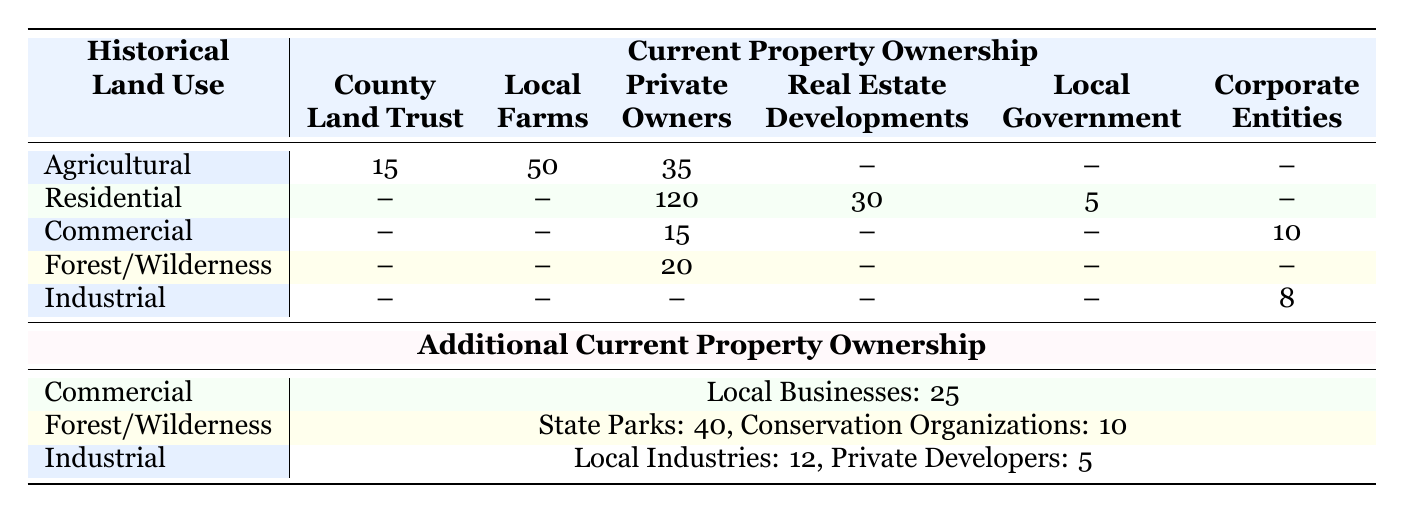What is the total number of current property ownership types under Agricultural land use? From the table, Agricultural has three ownership types: County Land Trust (15), Local Farms (50), Private Owners (35). Summing these amounts gives us 15 + 50 + 35 = 100.
Answer: 100 Which type of property ownership has the highest number under Residential land use? Looking at the Residential section, Private Owners have the highest number at 120, compared to Real Estate Developments (30) and Local Government (5).
Answer: Private Owners Is there a current property ownership type for Commercial land use that is recorded as zero? Observing the Commercial section, there are no ownership types listed as zero, as Local Businesses (25), Corporate Entities (10), and Private Owners (15) all have values greater than zero.
Answer: No What is the total number of current property ownership types for Forest/Wilderness land use? For Forest/Wilderness, there are three ownership types: State Parks (40), Private Owners (20), and Conservation Organizations (10). Adding these gives 40 + 20 + 10 = 70.
Answer: 70 How does the number of Local Farms compare to the total number of Local Businesses? Local Farms has a value of 50 while Local Businesses has a value of 25. If we subtract the two, 50 - 25 = 25, indicating that Local Farms has 25 more than Local Businesses.
Answer: Local Farms has 25 more What is the combined total of Private Owners across all land use types? To find this, we look at each land use type that has Private Owners: Agricultural (35), Residential (120), Commercial (15), Forest/Wilderness (20), and Industrial (0). Adding these gives 35 + 120 + 15 + 20 + 0 = 190.
Answer: 190 Is the total number of property ownership types under Industrial land use greater than or equal to those under Commercial land use? Industrial has three ownership types: Local Industries (12), Corporate Entities (8), and Private Developers (5) totaling 12 + 8 + 5 = 25. Commercial has three ownership types: Local Businesses (25), Private Owners (15), and Corporate Entities (10) totaling 25 + 15 + 10 = 50. Since 25 is less than 50, the statement is false.
Answer: No What percentage of the current property ownership for Agricultural land use is owned by Local Farms? The number of Local Farms is 50, and the total ownership for Agricultural is 100. To find the percentage, we calculate (50/100) * 100 = 50%.
Answer: 50% 